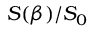Convert formula to latex. <formula><loc_0><loc_0><loc_500><loc_500>S ( \beta ) / S _ { 0 }</formula> 